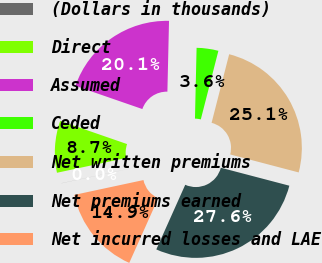<chart> <loc_0><loc_0><loc_500><loc_500><pie_chart><fcel>(Dollars in thousands)<fcel>Direct<fcel>Assumed<fcel>Ceded<fcel>Net written premiums<fcel>Net premiums earned<fcel>Net incurred losses and LAE<nl><fcel>0.01%<fcel>8.66%<fcel>20.06%<fcel>3.63%<fcel>25.09%<fcel>27.62%<fcel>14.94%<nl></chart> 